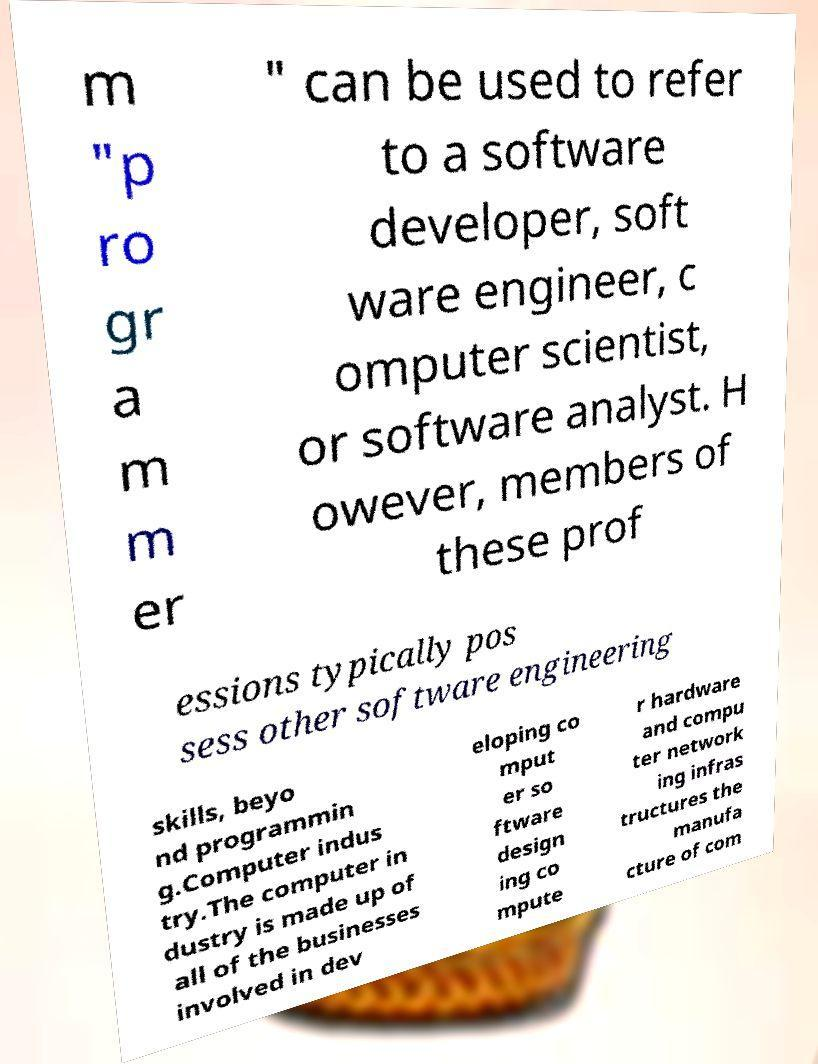I need the written content from this picture converted into text. Can you do that? m "p ro gr a m m er " can be used to refer to a software developer, soft ware engineer, c omputer scientist, or software analyst. H owever, members of these prof essions typically pos sess other software engineering skills, beyo nd programmin g.Computer indus try.The computer in dustry is made up of all of the businesses involved in dev eloping co mput er so ftware design ing co mpute r hardware and compu ter network ing infras tructures the manufa cture of com 